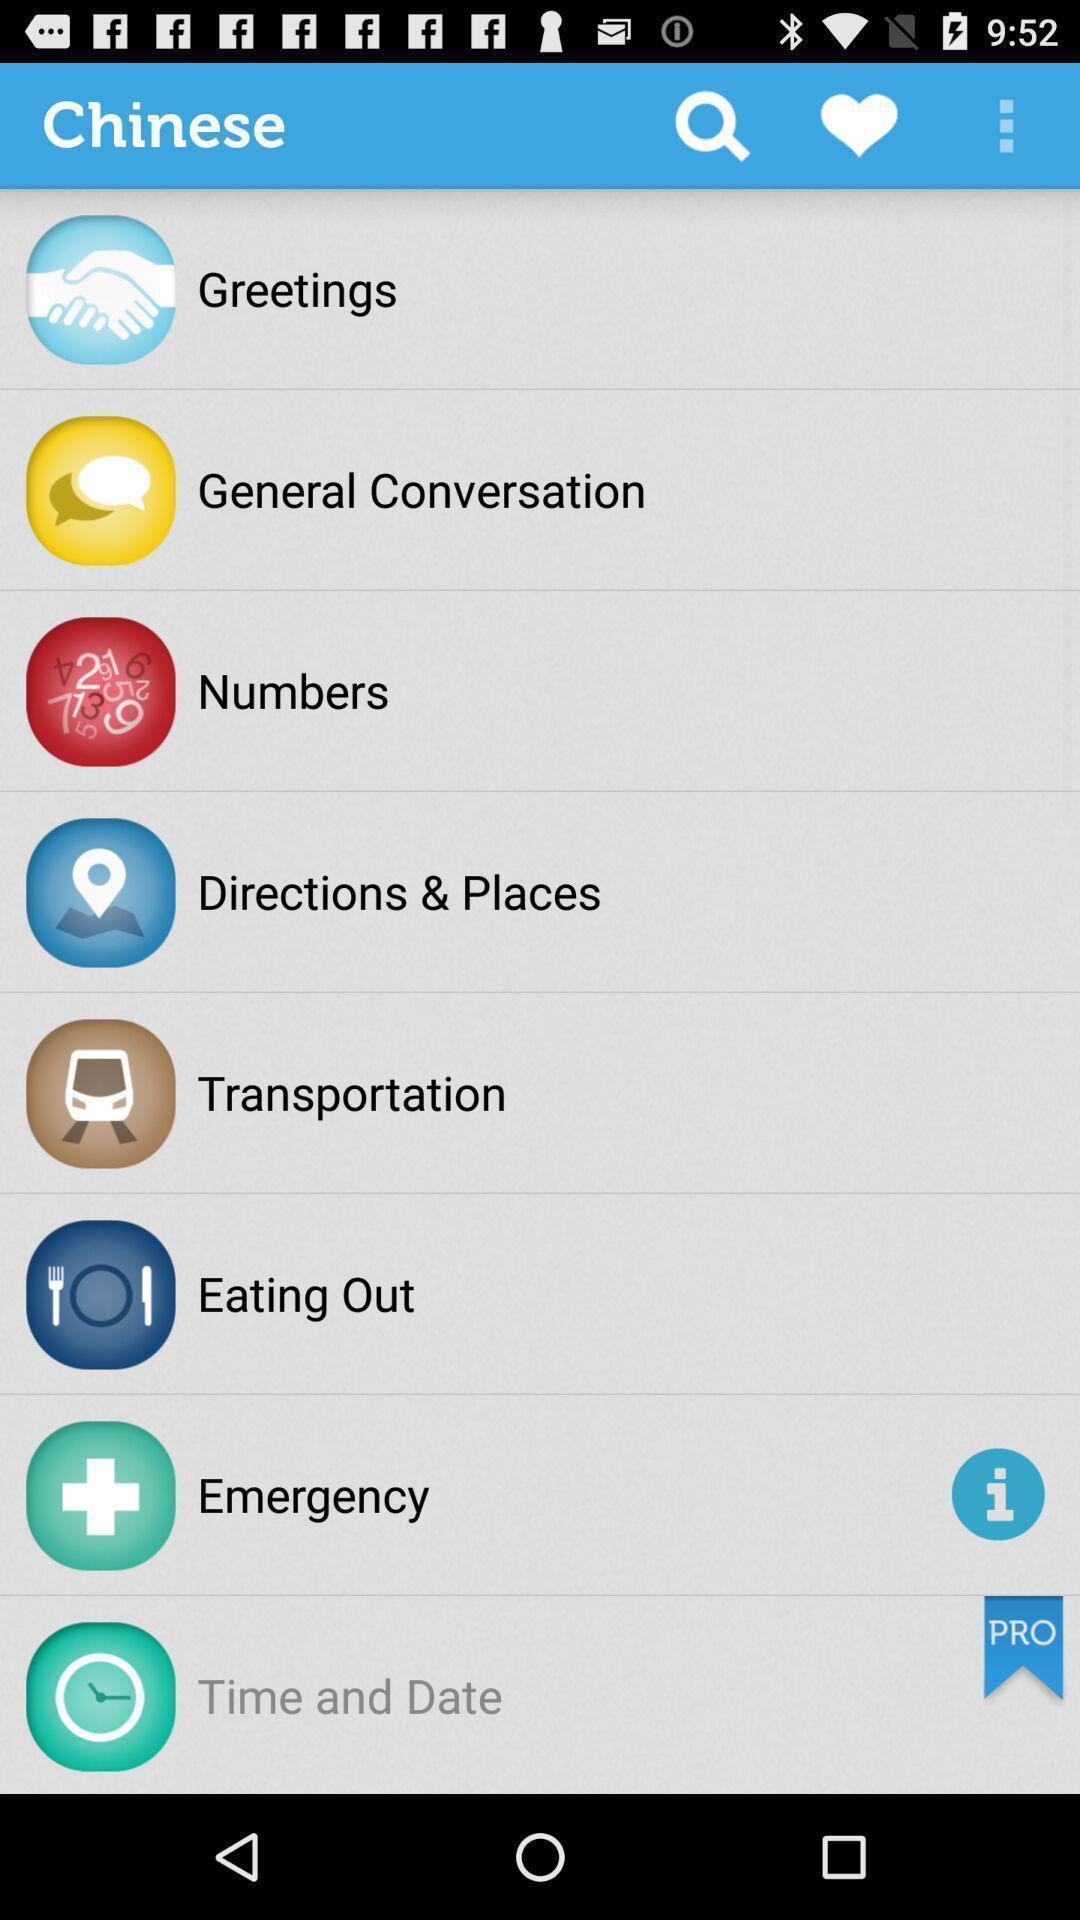Tell me what you see in this picture. Screen page displaying various categories. 